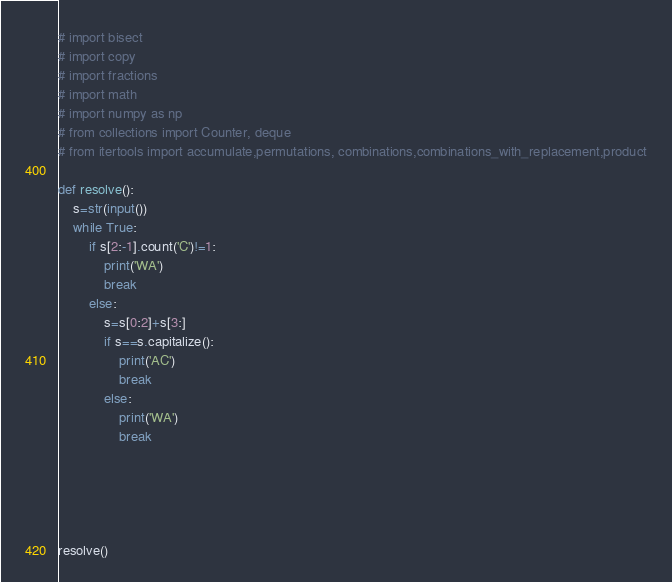Convert code to text. <code><loc_0><loc_0><loc_500><loc_500><_Python_># import bisect
# import copy
# import fractions
# import math
# import numpy as np
# from collections import Counter, deque
# from itertools import accumulate,permutations, combinations,combinations_with_replacement,product

def resolve():
    s=str(input())
    while True:
        if s[2:-1].count('C')!=1:
            print('WA')
            break
        else:
            s=s[0:2]+s[3:]
            if s==s.capitalize():
                print('AC')
                break
            else:
                print('WA')
                break





resolve()</code> 